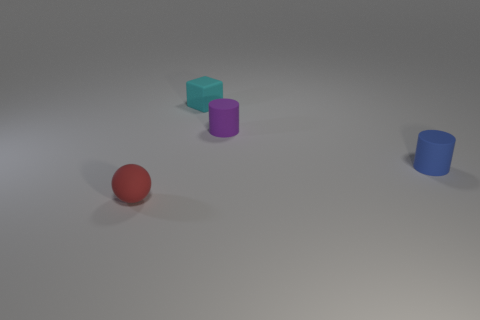Add 2 large blue shiny cubes. How many objects exist? 6 Subtract all balls. How many objects are left? 3 Subtract all large brown matte balls. Subtract all small cylinders. How many objects are left? 2 Add 3 rubber cylinders. How many rubber cylinders are left? 5 Add 1 tiny balls. How many tiny balls exist? 2 Subtract 1 blue cylinders. How many objects are left? 3 